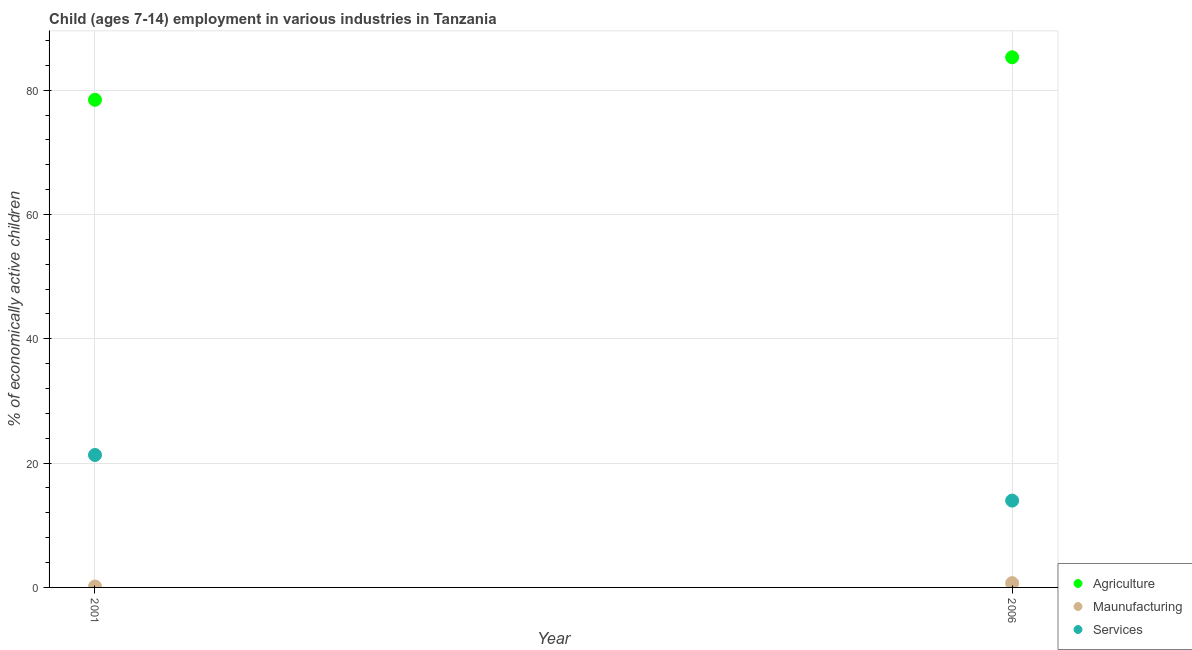How many different coloured dotlines are there?
Provide a short and direct response. 3. What is the percentage of economically active children in services in 2001?
Provide a succinct answer. 21.31. Across all years, what is the maximum percentage of economically active children in services?
Make the answer very short. 21.31. Across all years, what is the minimum percentage of economically active children in manufacturing?
Your response must be concise. 0.15. In which year was the percentage of economically active children in services minimum?
Your response must be concise. 2006. What is the total percentage of economically active children in manufacturing in the graph?
Your answer should be compact. 0.84. What is the difference between the percentage of economically active children in agriculture in 2001 and that in 2006?
Provide a succinct answer. -6.84. What is the difference between the percentage of economically active children in services in 2001 and the percentage of economically active children in agriculture in 2006?
Offer a terse response. -63.99. What is the average percentage of economically active children in manufacturing per year?
Your response must be concise. 0.42. In the year 2006, what is the difference between the percentage of economically active children in services and percentage of economically active children in agriculture?
Provide a succinct answer. -71.33. In how many years, is the percentage of economically active children in manufacturing greater than 68 %?
Give a very brief answer. 0. What is the ratio of the percentage of economically active children in manufacturing in 2001 to that in 2006?
Provide a short and direct response. 0.22. Is the percentage of economically active children in manufacturing in 2001 less than that in 2006?
Your answer should be very brief. Yes. Is the percentage of economically active children in services strictly greater than the percentage of economically active children in manufacturing over the years?
Make the answer very short. Yes. How many dotlines are there?
Offer a very short reply. 3. How many years are there in the graph?
Ensure brevity in your answer.  2. What is the difference between two consecutive major ticks on the Y-axis?
Offer a terse response. 20. Are the values on the major ticks of Y-axis written in scientific E-notation?
Your response must be concise. No. Does the graph contain any zero values?
Provide a short and direct response. No. Where does the legend appear in the graph?
Ensure brevity in your answer.  Bottom right. How are the legend labels stacked?
Give a very brief answer. Vertical. What is the title of the graph?
Your response must be concise. Child (ages 7-14) employment in various industries in Tanzania. What is the label or title of the X-axis?
Offer a very short reply. Year. What is the label or title of the Y-axis?
Offer a very short reply. % of economically active children. What is the % of economically active children in Agriculture in 2001?
Keep it short and to the point. 78.46. What is the % of economically active children in Maunufacturing in 2001?
Provide a succinct answer. 0.15. What is the % of economically active children of Services in 2001?
Ensure brevity in your answer.  21.31. What is the % of economically active children in Agriculture in 2006?
Provide a succinct answer. 85.3. What is the % of economically active children in Maunufacturing in 2006?
Your answer should be very brief. 0.69. What is the % of economically active children of Services in 2006?
Keep it short and to the point. 13.97. Across all years, what is the maximum % of economically active children in Agriculture?
Your answer should be very brief. 85.3. Across all years, what is the maximum % of economically active children in Maunufacturing?
Provide a short and direct response. 0.69. Across all years, what is the maximum % of economically active children in Services?
Ensure brevity in your answer.  21.31. Across all years, what is the minimum % of economically active children of Agriculture?
Give a very brief answer. 78.46. Across all years, what is the minimum % of economically active children of Maunufacturing?
Give a very brief answer. 0.15. Across all years, what is the minimum % of economically active children of Services?
Ensure brevity in your answer.  13.97. What is the total % of economically active children in Agriculture in the graph?
Your answer should be very brief. 163.76. What is the total % of economically active children of Maunufacturing in the graph?
Offer a very short reply. 0.84. What is the total % of economically active children in Services in the graph?
Your response must be concise. 35.28. What is the difference between the % of economically active children in Agriculture in 2001 and that in 2006?
Your response must be concise. -6.84. What is the difference between the % of economically active children in Maunufacturing in 2001 and that in 2006?
Provide a short and direct response. -0.54. What is the difference between the % of economically active children in Services in 2001 and that in 2006?
Make the answer very short. 7.34. What is the difference between the % of economically active children of Agriculture in 2001 and the % of economically active children of Maunufacturing in 2006?
Provide a succinct answer. 77.77. What is the difference between the % of economically active children in Agriculture in 2001 and the % of economically active children in Services in 2006?
Make the answer very short. 64.49. What is the difference between the % of economically active children in Maunufacturing in 2001 and the % of economically active children in Services in 2006?
Offer a terse response. -13.82. What is the average % of economically active children of Agriculture per year?
Offer a very short reply. 81.88. What is the average % of economically active children of Maunufacturing per year?
Keep it short and to the point. 0.42. What is the average % of economically active children in Services per year?
Your answer should be compact. 17.64. In the year 2001, what is the difference between the % of economically active children in Agriculture and % of economically active children in Maunufacturing?
Make the answer very short. 78.31. In the year 2001, what is the difference between the % of economically active children in Agriculture and % of economically active children in Services?
Offer a very short reply. 57.15. In the year 2001, what is the difference between the % of economically active children in Maunufacturing and % of economically active children in Services?
Offer a terse response. -21.16. In the year 2006, what is the difference between the % of economically active children in Agriculture and % of economically active children in Maunufacturing?
Your answer should be compact. 84.61. In the year 2006, what is the difference between the % of economically active children in Agriculture and % of economically active children in Services?
Your answer should be very brief. 71.33. In the year 2006, what is the difference between the % of economically active children of Maunufacturing and % of economically active children of Services?
Offer a terse response. -13.28. What is the ratio of the % of economically active children of Agriculture in 2001 to that in 2006?
Give a very brief answer. 0.92. What is the ratio of the % of economically active children of Maunufacturing in 2001 to that in 2006?
Offer a very short reply. 0.22. What is the ratio of the % of economically active children in Services in 2001 to that in 2006?
Your answer should be compact. 1.53. What is the difference between the highest and the second highest % of economically active children in Agriculture?
Offer a terse response. 6.84. What is the difference between the highest and the second highest % of economically active children of Maunufacturing?
Your response must be concise. 0.54. What is the difference between the highest and the second highest % of economically active children of Services?
Ensure brevity in your answer.  7.34. What is the difference between the highest and the lowest % of economically active children in Agriculture?
Offer a terse response. 6.84. What is the difference between the highest and the lowest % of economically active children of Maunufacturing?
Your response must be concise. 0.54. What is the difference between the highest and the lowest % of economically active children of Services?
Your response must be concise. 7.34. 